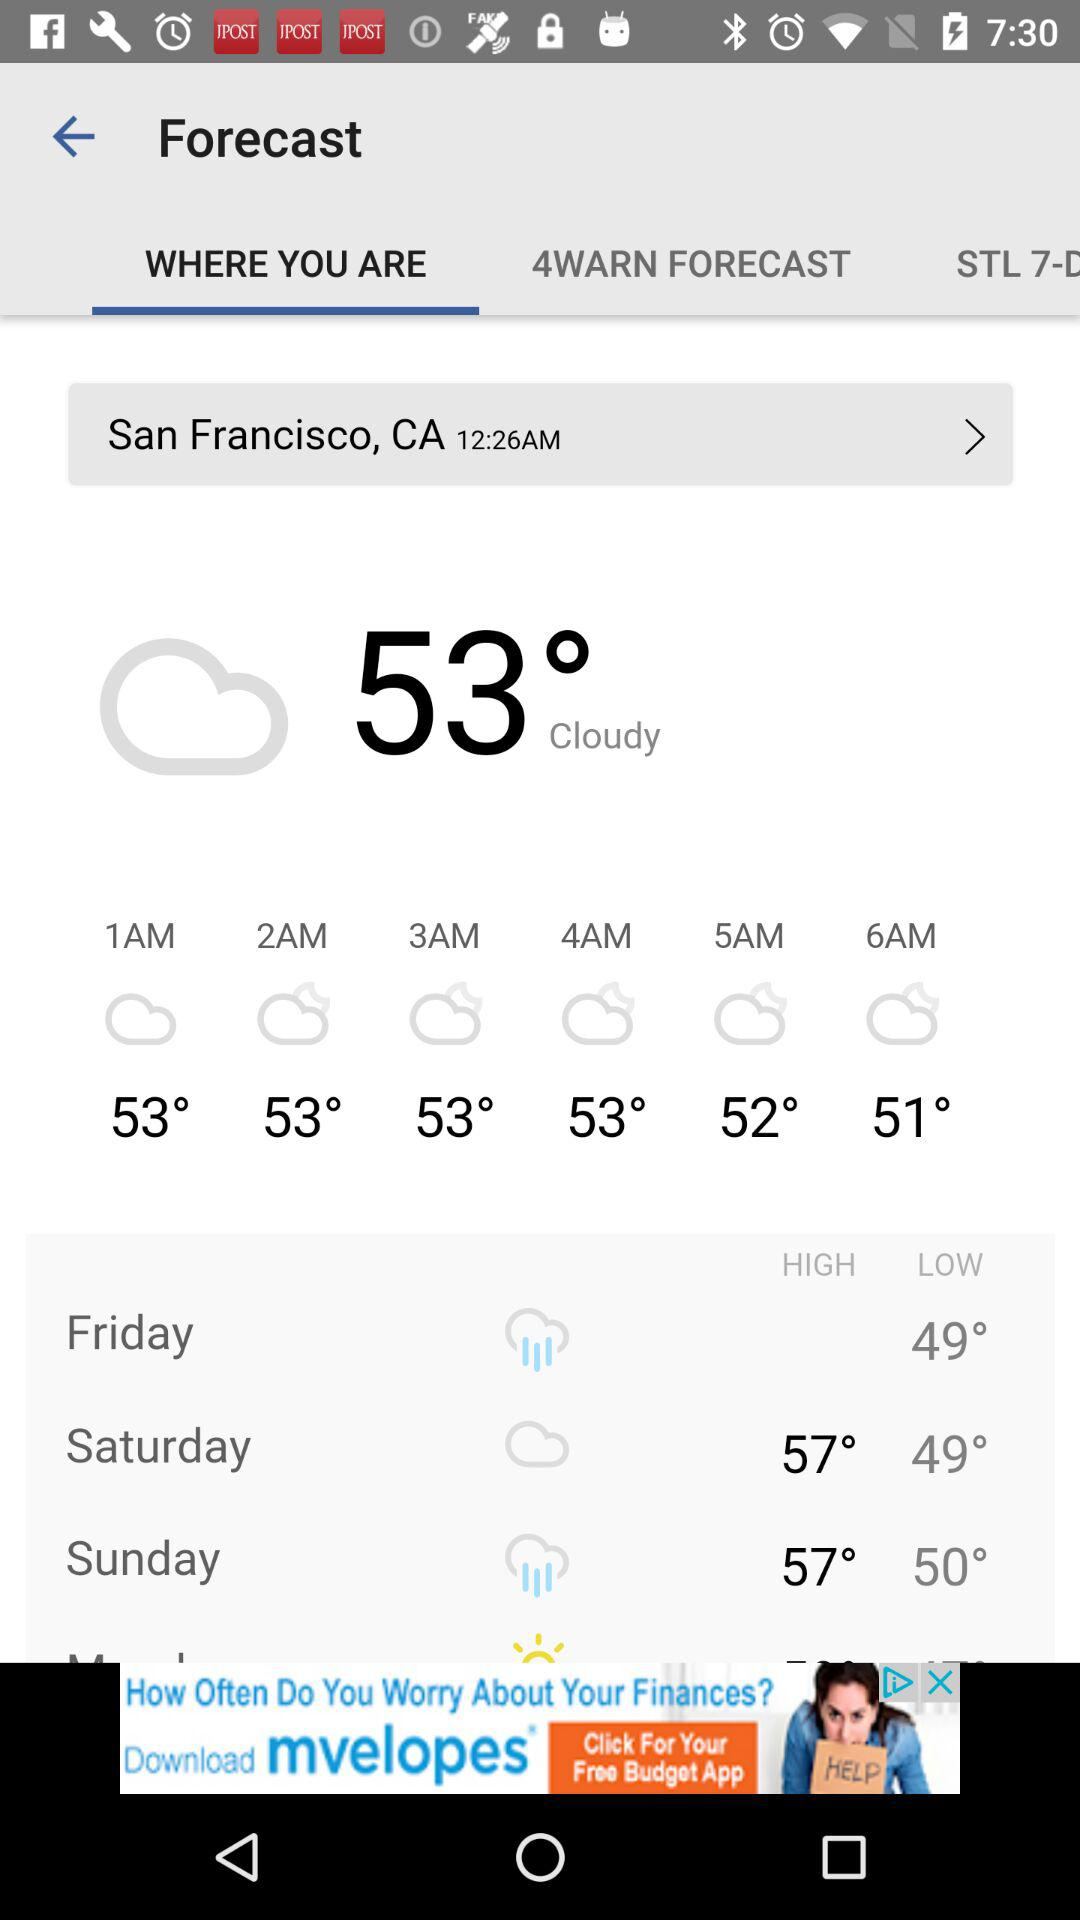What is the weather forecast for saturday?
When the provided information is insufficient, respond with <no answer>. <no answer> 